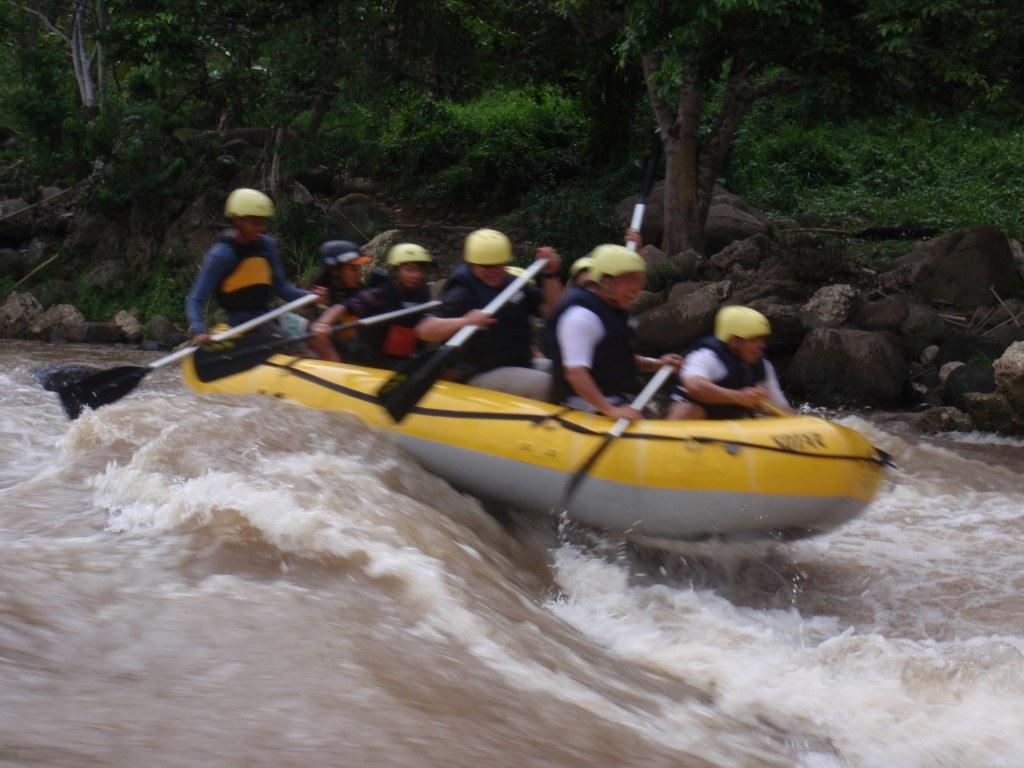What type of natural environment can be seen in the background of the image? There are trees and rocks in the background of the image. What objects are the people holding in their hands? The people are holding paddles in their hands. What protective gear are the people wearing? The people are wearing helmets. What activity are the people participating in? The people are participating in rafting. How many apples are being used as paddles in the image? There are no apples being used as paddles in the image; the people are holding regular paddles. What type of peace symbol can be seen in the image? There is no peace symbol present in the image. 